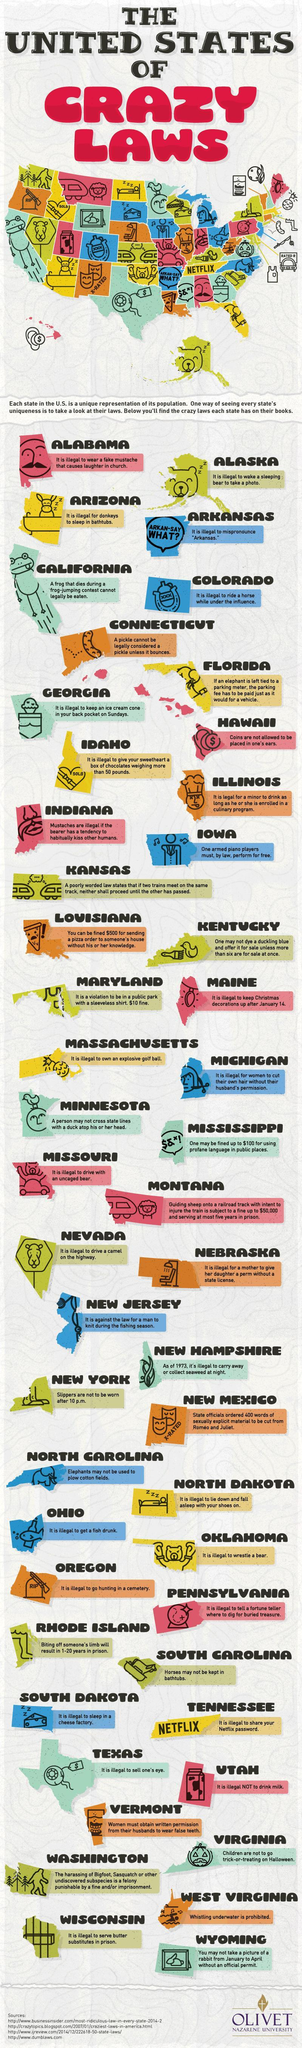What is the crazy law in Maine?
Answer the question with a short phrase. It is illegal to keep Christmas decorations up after January 14. 